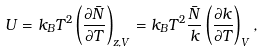Convert formula to latex. <formula><loc_0><loc_0><loc_500><loc_500>U = k _ { B } T ^ { 2 } \left ( \frac { \partial \bar { N } } { \partial T } \right ) _ { z , V } = k _ { B } T ^ { 2 } \frac { \bar { N } } { k } \left ( \frac { \partial k } { \partial T } \right ) _ { V } ,</formula> 